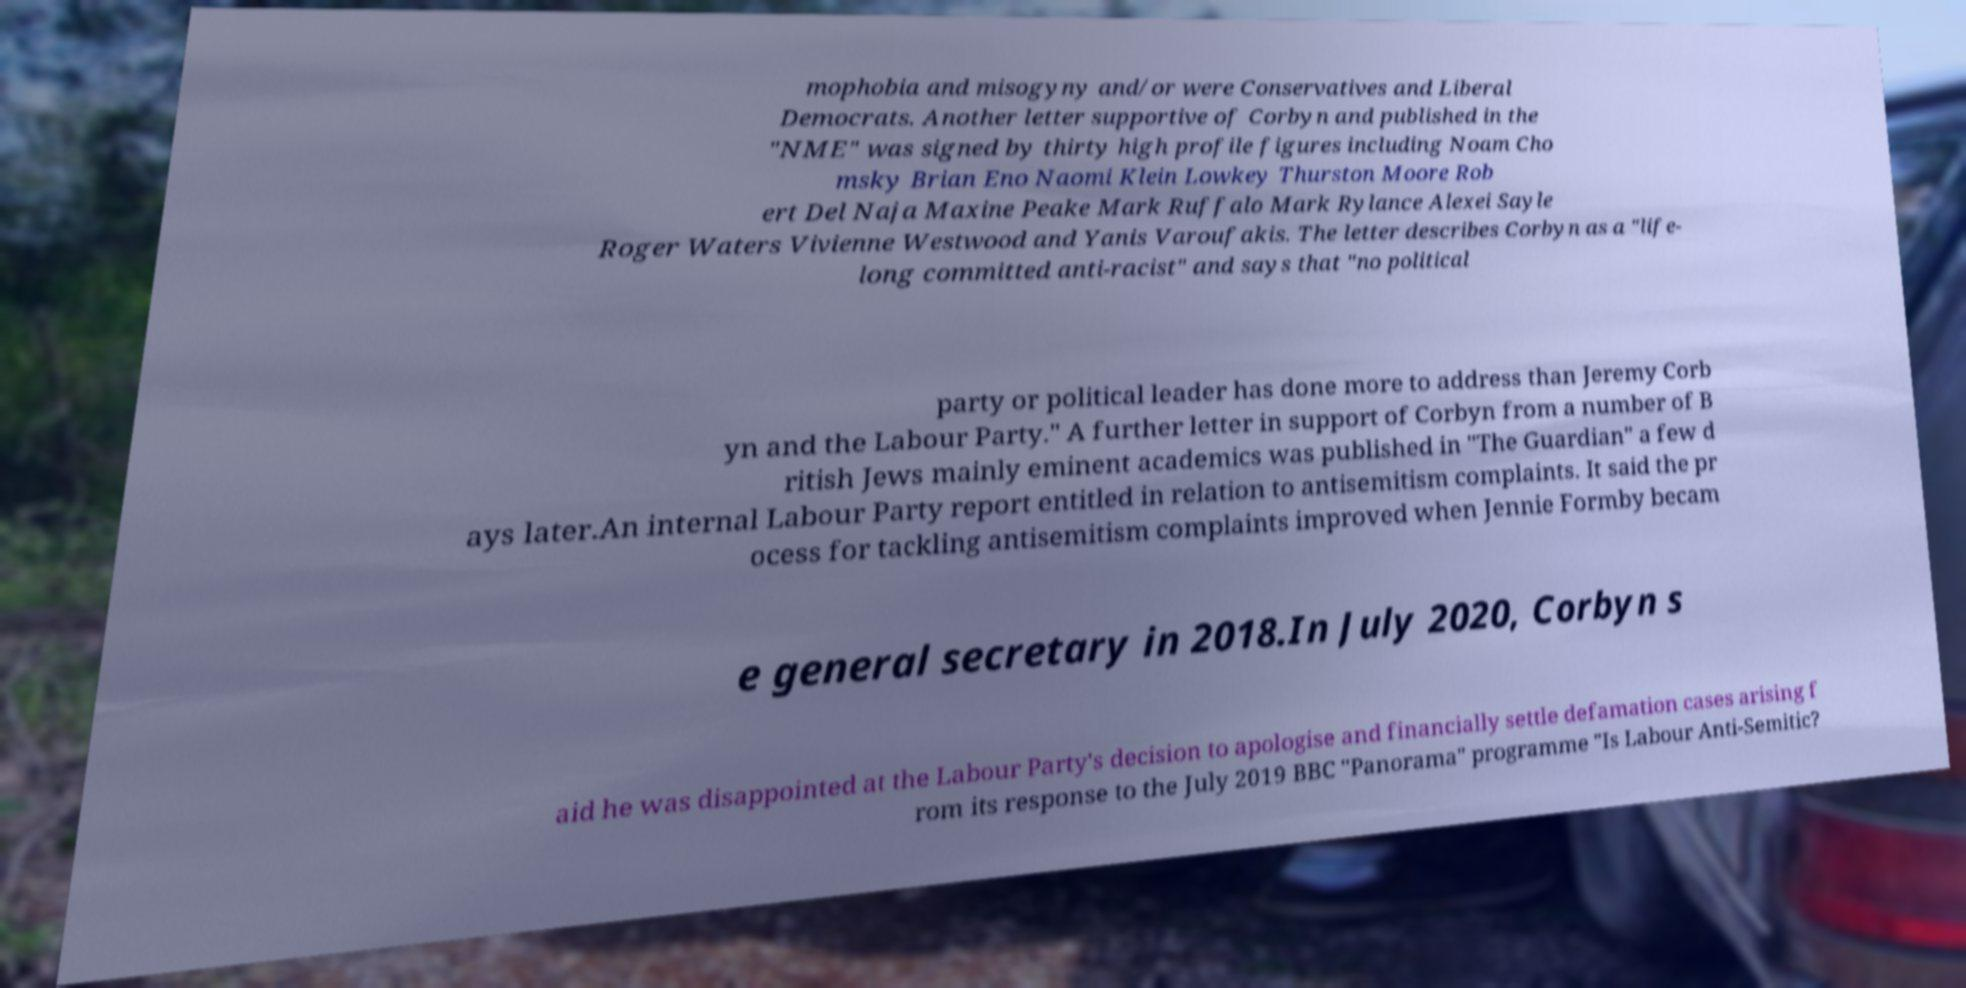For documentation purposes, I need the text within this image transcribed. Could you provide that? mophobia and misogyny and/or were Conservatives and Liberal Democrats. Another letter supportive of Corbyn and published in the "NME" was signed by thirty high profile figures including Noam Cho msky Brian Eno Naomi Klein Lowkey Thurston Moore Rob ert Del Naja Maxine Peake Mark Ruffalo Mark Rylance Alexei Sayle Roger Waters Vivienne Westwood and Yanis Varoufakis. The letter describes Corbyn as a "life- long committed anti-racist" and says that "no political party or political leader has done more to address than Jeremy Corb yn and the Labour Party." A further letter in support of Corbyn from a number of B ritish Jews mainly eminent academics was published in "The Guardian" a few d ays later.An internal Labour Party report entitled in relation to antisemitism complaints. It said the pr ocess for tackling antisemitism complaints improved when Jennie Formby becam e general secretary in 2018.In July 2020, Corbyn s aid he was disappointed at the Labour Party's decision to apologise and financially settle defamation cases arising f rom its response to the July 2019 BBC "Panorama" programme "Is Labour Anti-Semitic? 